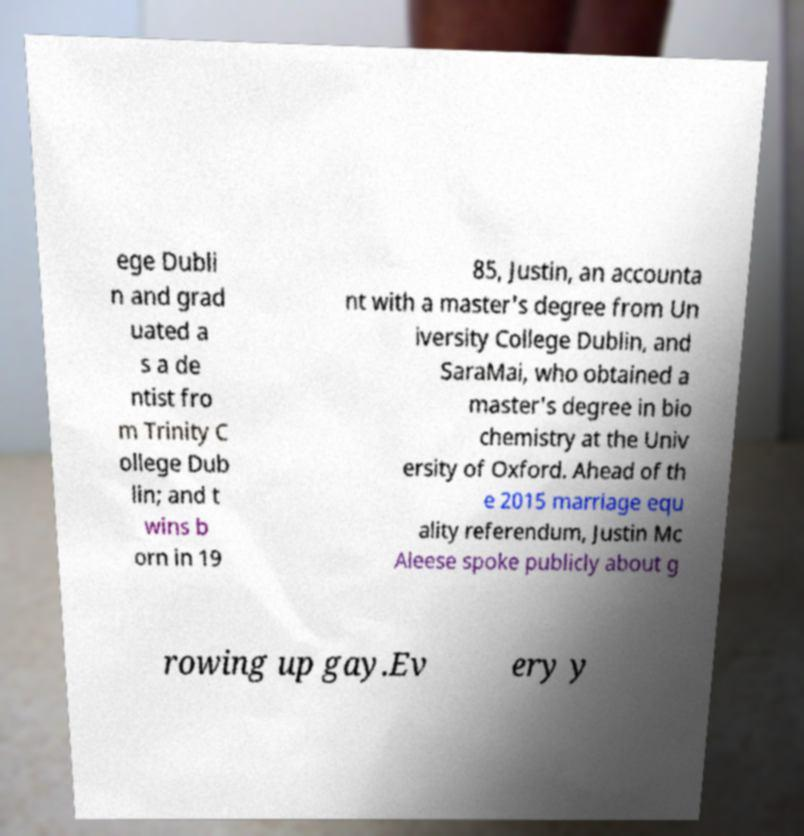Could you assist in decoding the text presented in this image and type it out clearly? ege Dubli n and grad uated a s a de ntist fro m Trinity C ollege Dub lin; and t wins b orn in 19 85, Justin, an accounta nt with a master's degree from Un iversity College Dublin, and SaraMai, who obtained a master's degree in bio chemistry at the Univ ersity of Oxford. Ahead of th e 2015 marriage equ ality referendum, Justin Mc Aleese spoke publicly about g rowing up gay.Ev ery y 